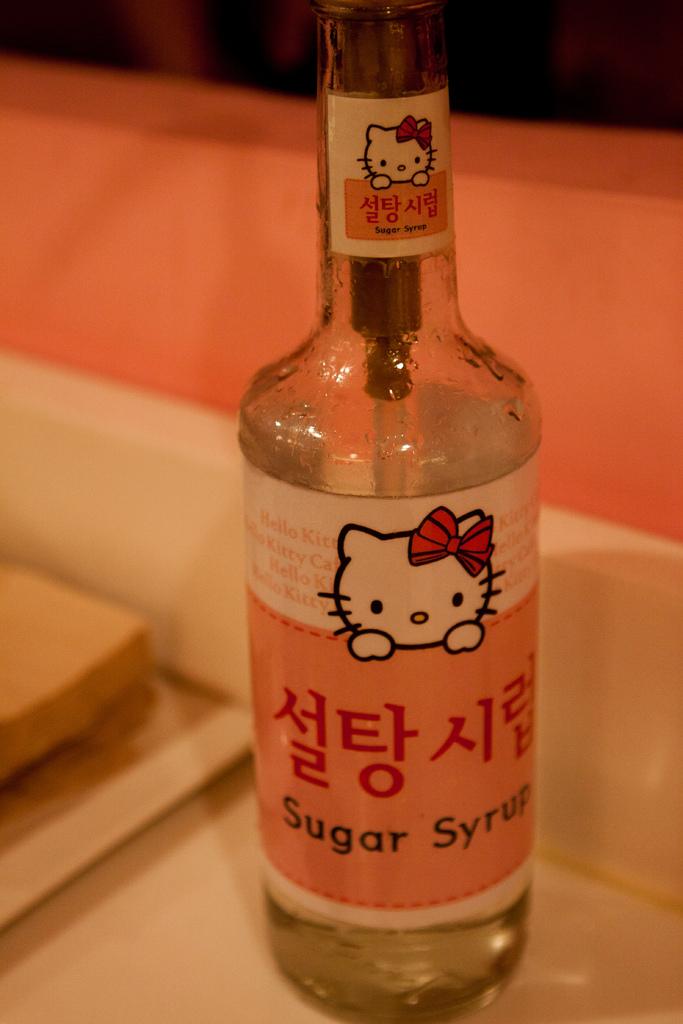What type of syrup is in the bottle?
Your answer should be compact. Sugar. What brand is it?
Make the answer very short. Hello kitty. 